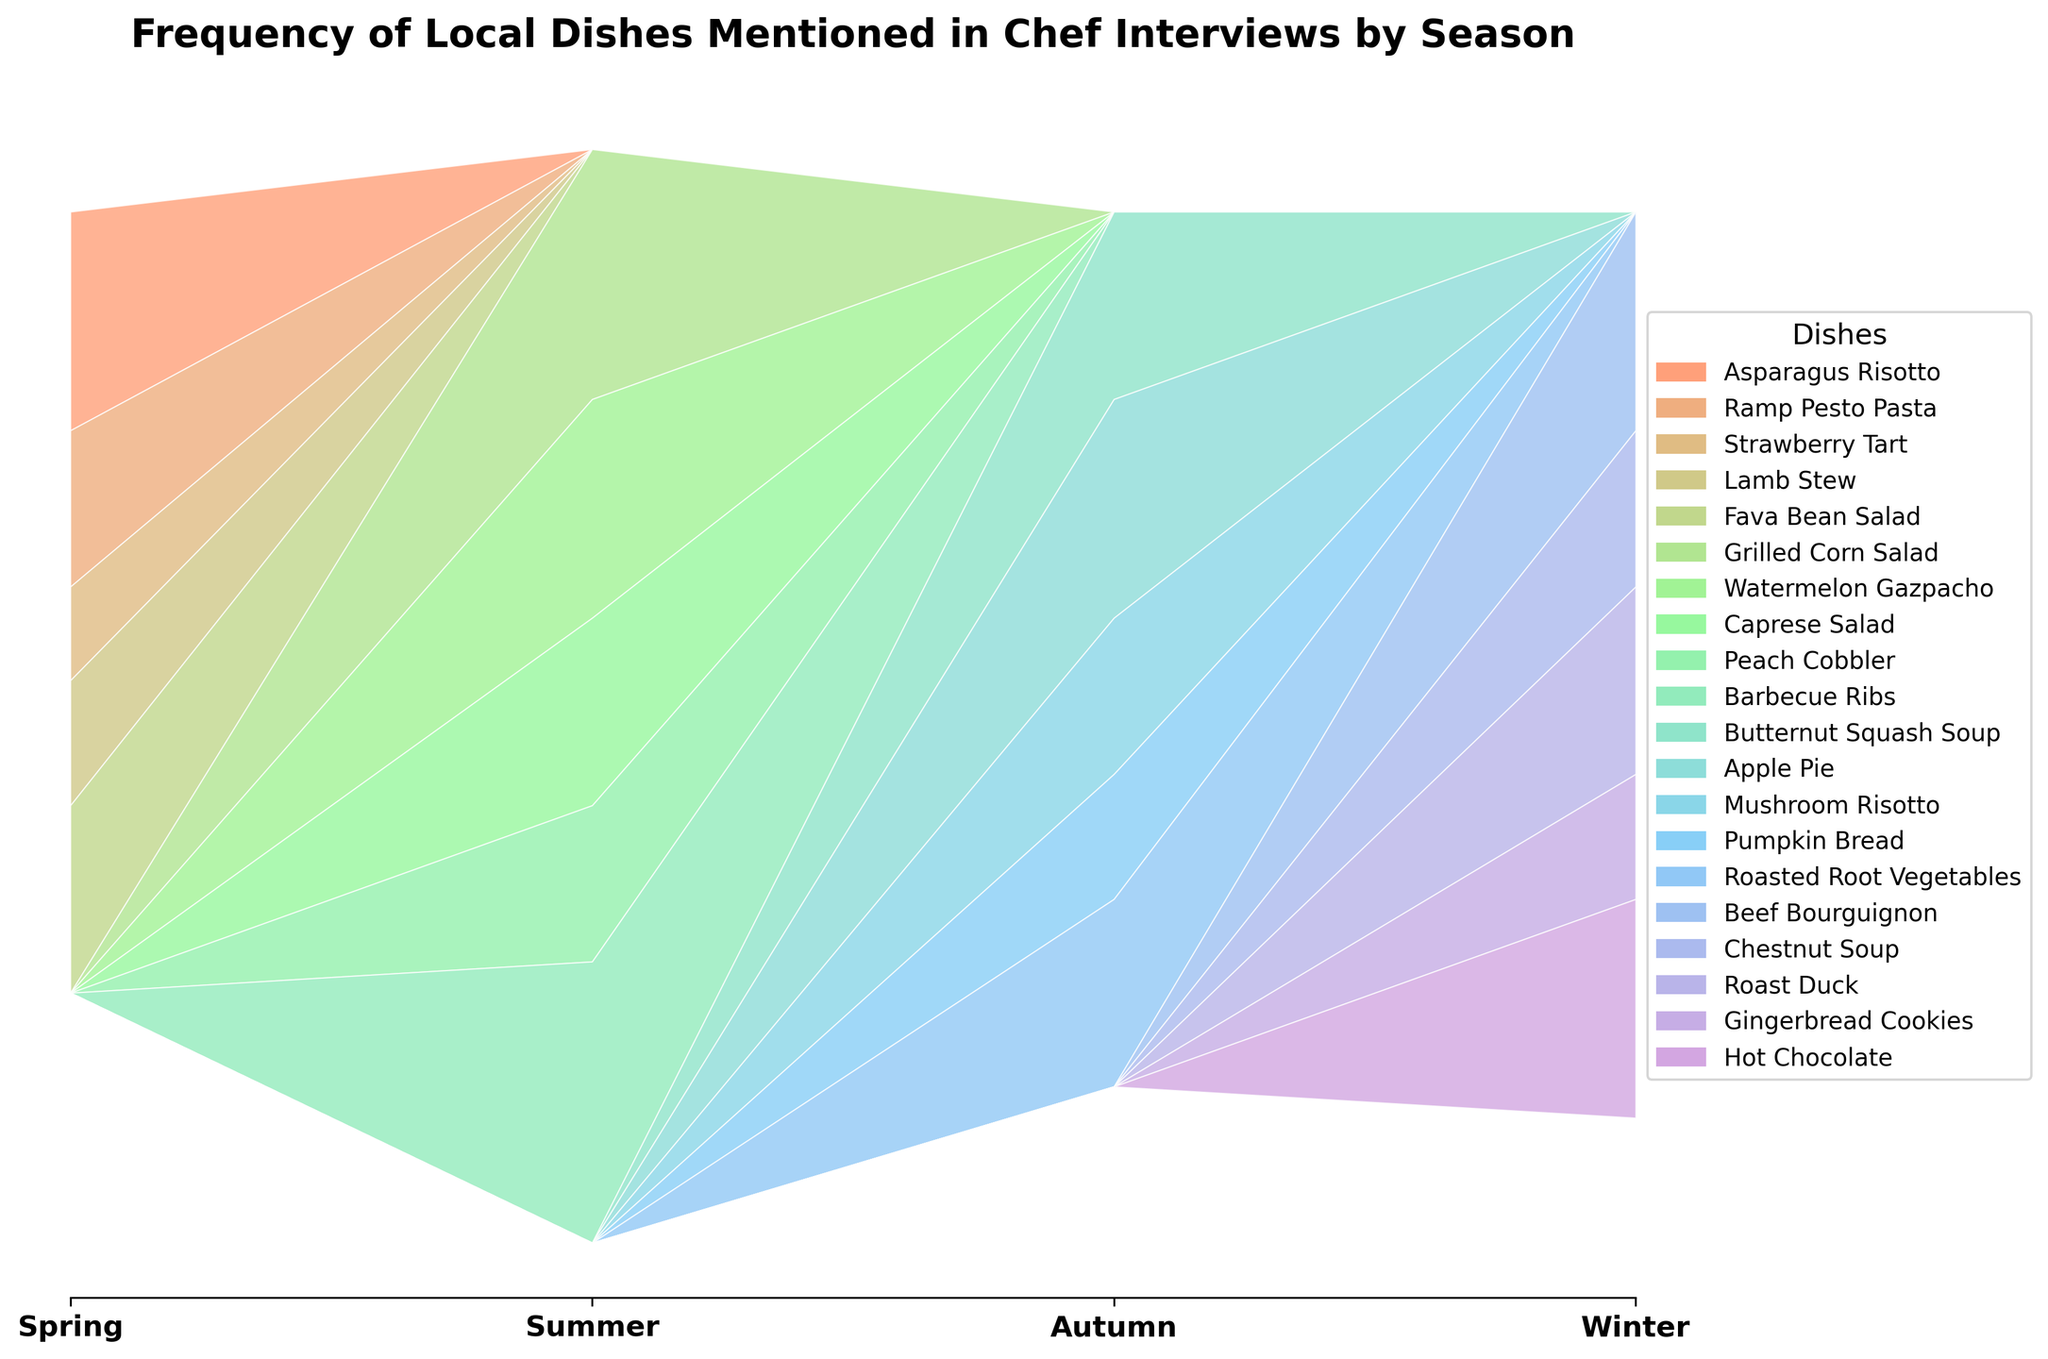What's the title of the graph? The title of the graph is displayed at the top, which states the main subject of the visualization. The title is "Frequency of Local Dishes Mentioned in Chef Interviews by Season".
Answer: Frequency of Local Dishes Mentioned in Chef Interviews by Season What are the four seasons represented in the graph? The x-axis labels indicate the four seasons shown in the graph. They are Spring, Summer, Autumn, and Winter.
Answer: Spring, Summer, Autumn, Winter Which dish has the highest mentions during Summer? Looking at the Summer section, the dish with the widest band or area is the one with the highest mentions. Barbecue Ribs has the widest area in the Summer season.
Answer: Barbecue Ribs How many mentions does Strawberry Tart have in Spring? In the legend, find the corresponding color for Strawberry Tart. Then, trace this color to the Spring band to identify the number of mentions. Strawberry Tart has 3 mentions in Spring.
Answer: 3 What's the cumulative number of mentions for all dishes in Winter? Sum the heights of all the bands in the Winter section. The dishes and their mentions are Beef Bourguignon (7), Chestnut Soup (5), Roast Duck (6), Gingerbread Cookies (4), and Hot Chocolate (7). The cumulative number of mentions is 7+5+6+4+7=29.
Answer: 29 Which season has the lowest cumulative mentions across all dishes? Calculate the total mentions for each season by adding up the values of all dishes in each season. The season with the smallest sum is the one with the lowest cumulative mentions. Autumn has the lowest cumulative mentions, with totals Butternut Squash Soup (6), Apple Pie (7), Mushroom Risotto (5), Pumpkin Bread (4), and Roasted Root Vegetables (6), summing up to 6+7+5+4+6=28.
Answer: Autumn In which season is Watermelon Gazpacho mentioned the most? Following the color associated with Watermelon Gazpacho from the legend, observe its representation across different seasons. Watermelon Gazpacho has mentions only in Summer.
Answer: Summer Among all dishes, which one is least mentioned in Autumn? Compare the height of each dish's band in Autumn. The dish with the smallest height or area is the least mentioned. Pumpkin Bread has the smallest area, indicating 4 mentions.
Answer: Pumpkin Bread 